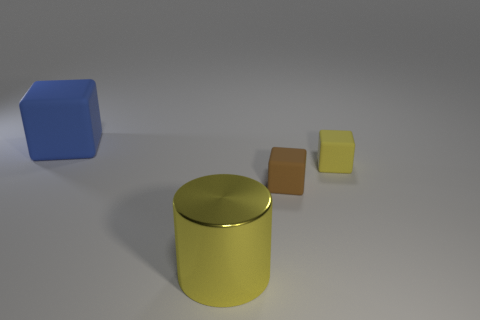Is there a blue thing that has the same material as the blue cube?
Make the answer very short. No. Do the big metal cylinder and the large cube have the same color?
Your answer should be compact. No. There is a thing that is on the left side of the small brown matte cube and behind the metallic cylinder; what is its material?
Make the answer very short. Rubber. The shiny thing is what color?
Ensure brevity in your answer.  Yellow. What number of other shiny things have the same shape as the metallic thing?
Your answer should be very brief. 0. Are the yellow thing that is behind the large yellow cylinder and the big thing behind the brown object made of the same material?
Give a very brief answer. Yes. How big is the rubber block that is left of the large object that is in front of the big blue matte object?
Give a very brief answer. Large. Is there any other thing that has the same size as the yellow block?
Keep it short and to the point. Yes. There is a yellow object that is the same shape as the large blue thing; what is it made of?
Give a very brief answer. Rubber. Does the big object that is in front of the tiny brown cube have the same shape as the small matte object that is behind the brown matte cube?
Provide a short and direct response. No. 